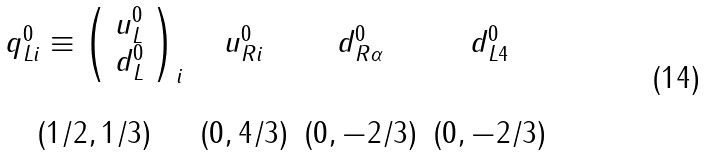Convert formula to latex. <formula><loc_0><loc_0><loc_500><loc_500>\begin{array} { c c c c } q _ { L i } ^ { 0 } \equiv \left ( \begin{array} { c } u _ { L } ^ { 0 } \\ d _ { L } ^ { 0 } \end{array} \right ) _ { i } & u _ { R i } ^ { 0 } & d _ { R \alpha } ^ { 0 } & d _ { L 4 } ^ { 0 } \\ \\ ( 1 / 2 , 1 / 3 ) & ( 0 , 4 / 3 ) & ( 0 , - 2 / 3 ) & ( 0 , - 2 / 3 ) \end{array}</formula> 